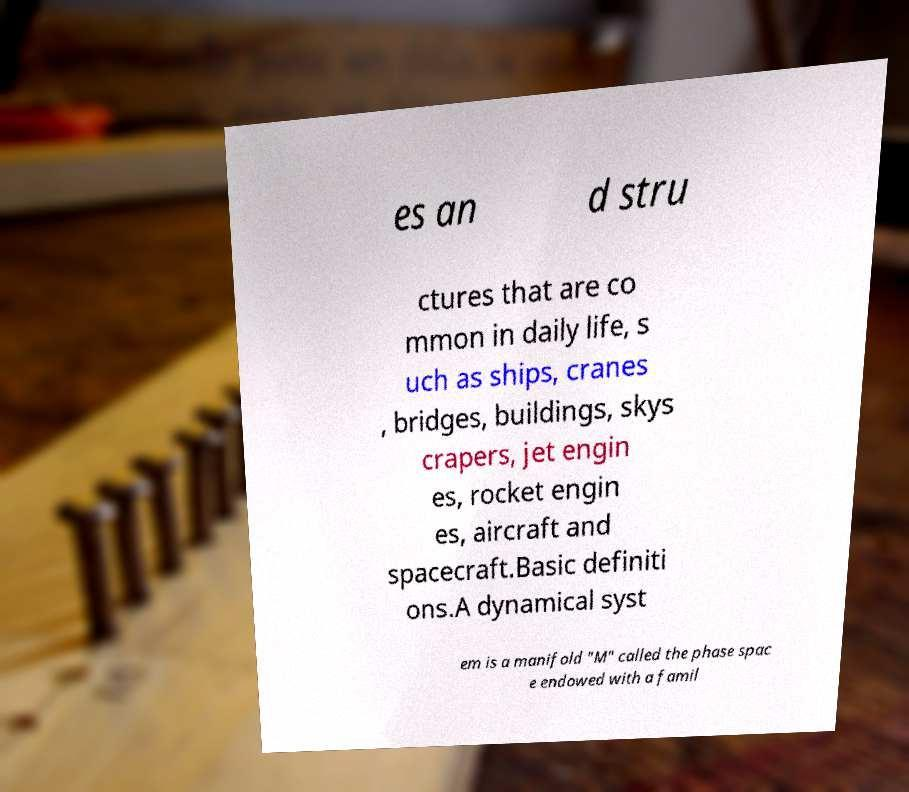Could you assist in decoding the text presented in this image and type it out clearly? es an d stru ctures that are co mmon in daily life, s uch as ships, cranes , bridges, buildings, skys crapers, jet engin es, rocket engin es, aircraft and spacecraft.Basic definiti ons.A dynamical syst em is a manifold "M" called the phase spac e endowed with a famil 